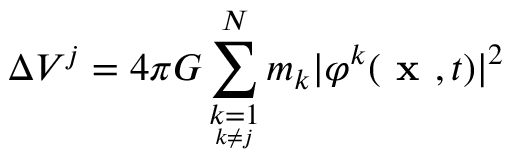Convert formula to latex. <formula><loc_0><loc_0><loc_500><loc_500>\Delta V ^ { j } = 4 \pi G \sum _ { \underset { k \neq j } { k = 1 } } ^ { N } m _ { k } | \varphi ^ { k } ( x , t ) | ^ { 2 }</formula> 